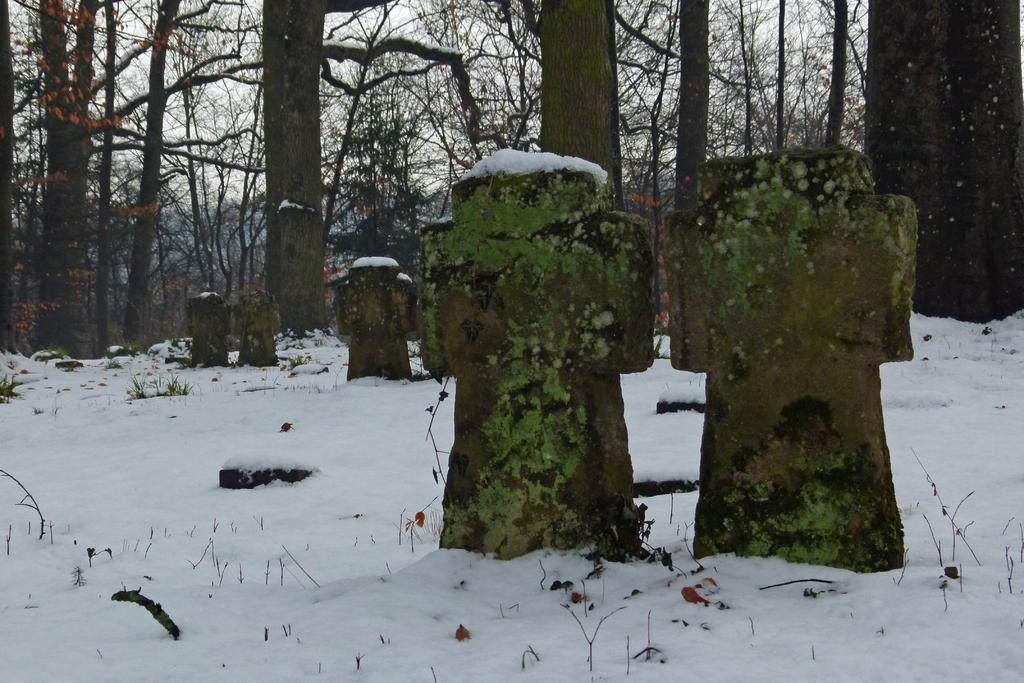What can be seen in the foreground of the picture? In the foreground of the picture, there are gravestones, snow, grass, and twigs. What is the condition of the ground in the foreground? The ground in the foreground is covered in snow and has grass and twigs. What is visible in the background of the picture? There are trees in the background of the picture. Can you see any goldfish swimming in the snow in the foreground of the image? There are no goldfish present in the image; it features gravestones, snow, grass, and twigs in the foreground. Is there a road visible in the image? There is no road visible in the image; it only shows gravestones, snow, grass, twigs, and trees. 